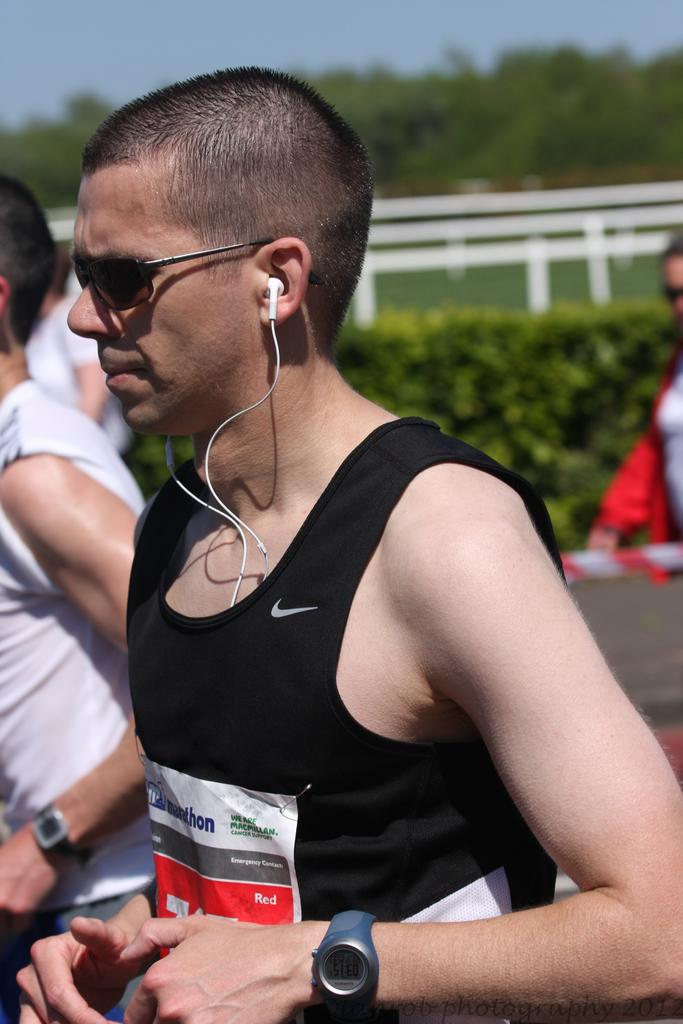What are the persons in the image doing? The persons in the image are running. Can you describe the clothing of the man in the center? The man in the center is wearing a black color cloth. What can be seen in the background of the image? There are trees in the background of the image. What type of nut is being used to shake the tree in the image? There is no nut or tree-shaking activity present in the image. Is there a tent visible in the image? No, there is no tent present in the image. 